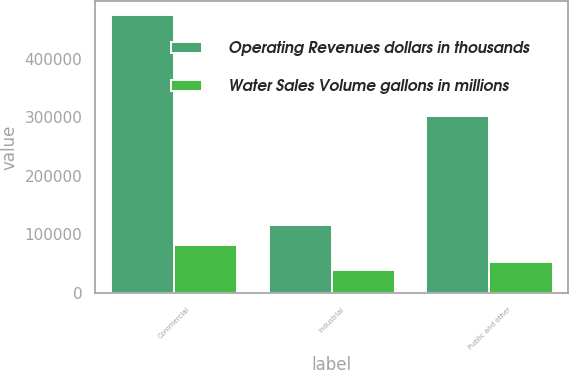<chart> <loc_0><loc_0><loc_500><loc_500><stacked_bar_chart><ecel><fcel>Commercial<fcel>Industrial<fcel>Public and other<nl><fcel>Operating Revenues dollars in thousands<fcel>474191<fcel>115981<fcel>302276<nl><fcel>Water Sales Volume gallons in millions<fcel>81455<fcel>39295<fcel>52069<nl></chart> 